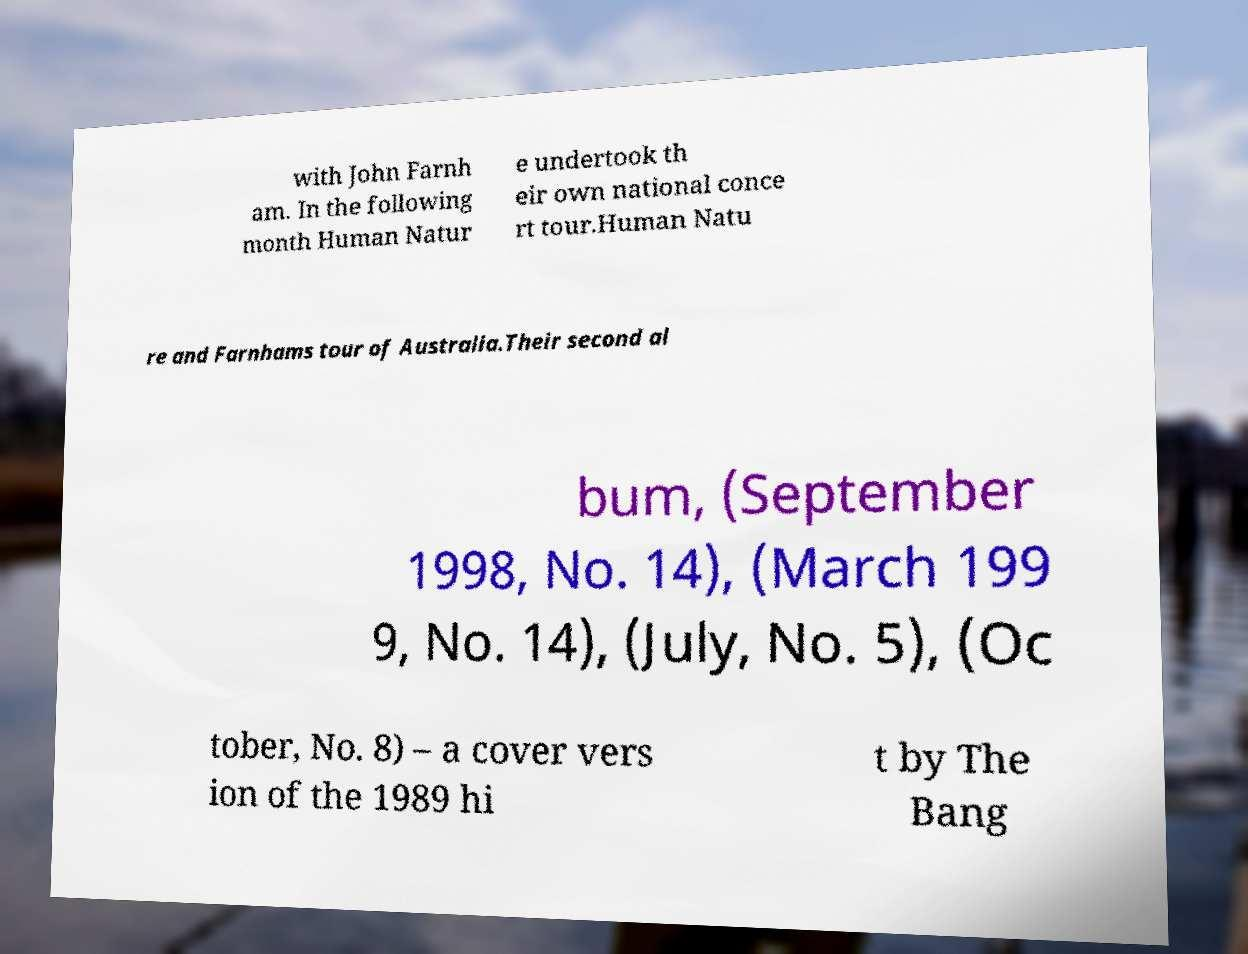Can you accurately transcribe the text from the provided image for me? with John Farnh am. In the following month Human Natur e undertook th eir own national conce rt tour.Human Natu re and Farnhams tour of Australia.Their second al bum, (September 1998, No. 14), (March 199 9, No. 14), (July, No. 5), (Oc tober, No. 8) – a cover vers ion of the 1989 hi t by The Bang 